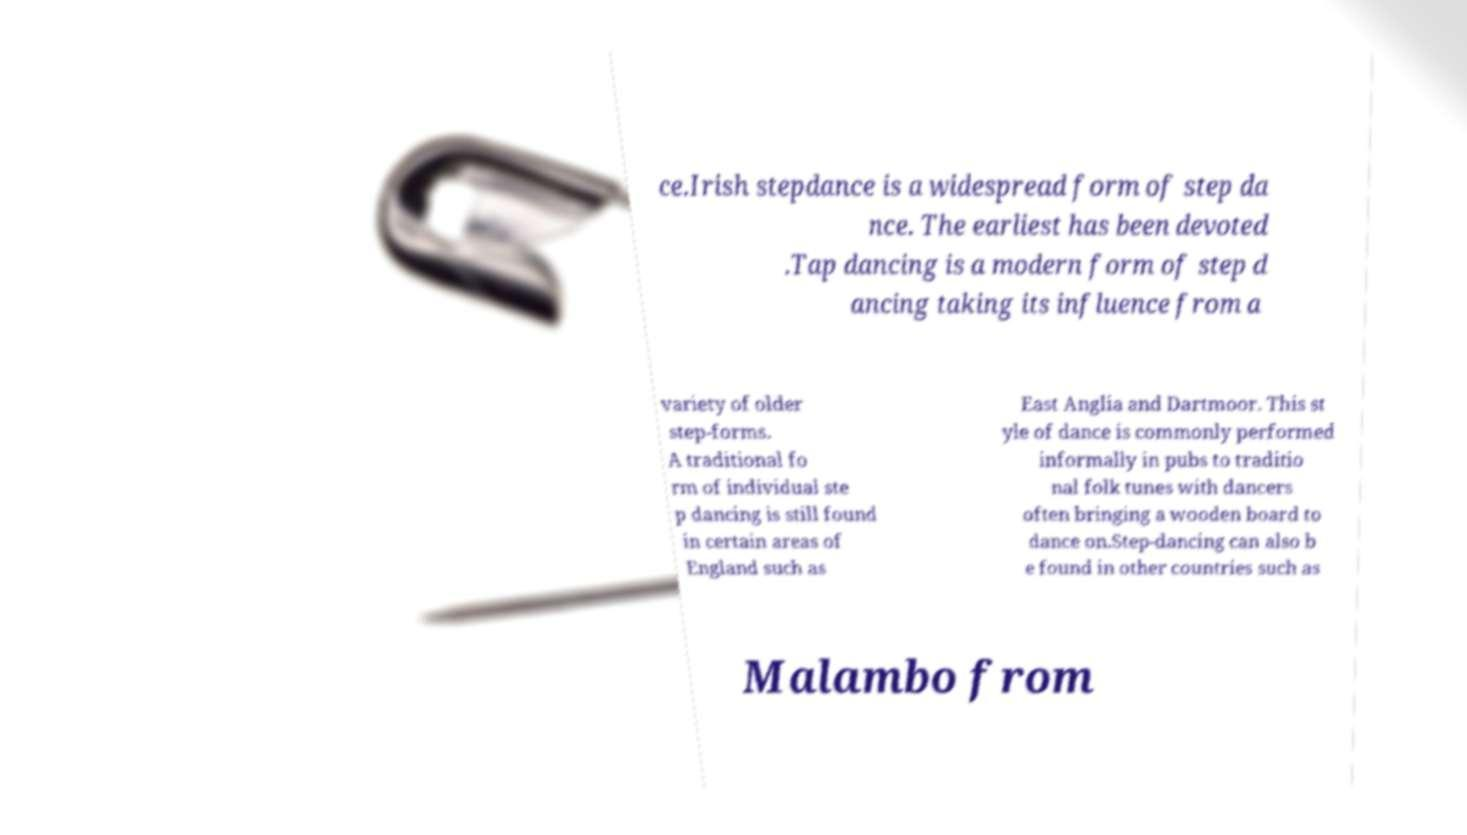Please identify and transcribe the text found in this image. ce.Irish stepdance is a widespread form of step da nce. The earliest has been devoted .Tap dancing is a modern form of step d ancing taking its influence from a variety of older step-forms. A traditional fo rm of individual ste p dancing is still found in certain areas of England such as East Anglia and Dartmoor. This st yle of dance is commonly performed informally in pubs to traditio nal folk tunes with dancers often bringing a wooden board to dance on.Step-dancing can also b e found in other countries such as Malambo from 